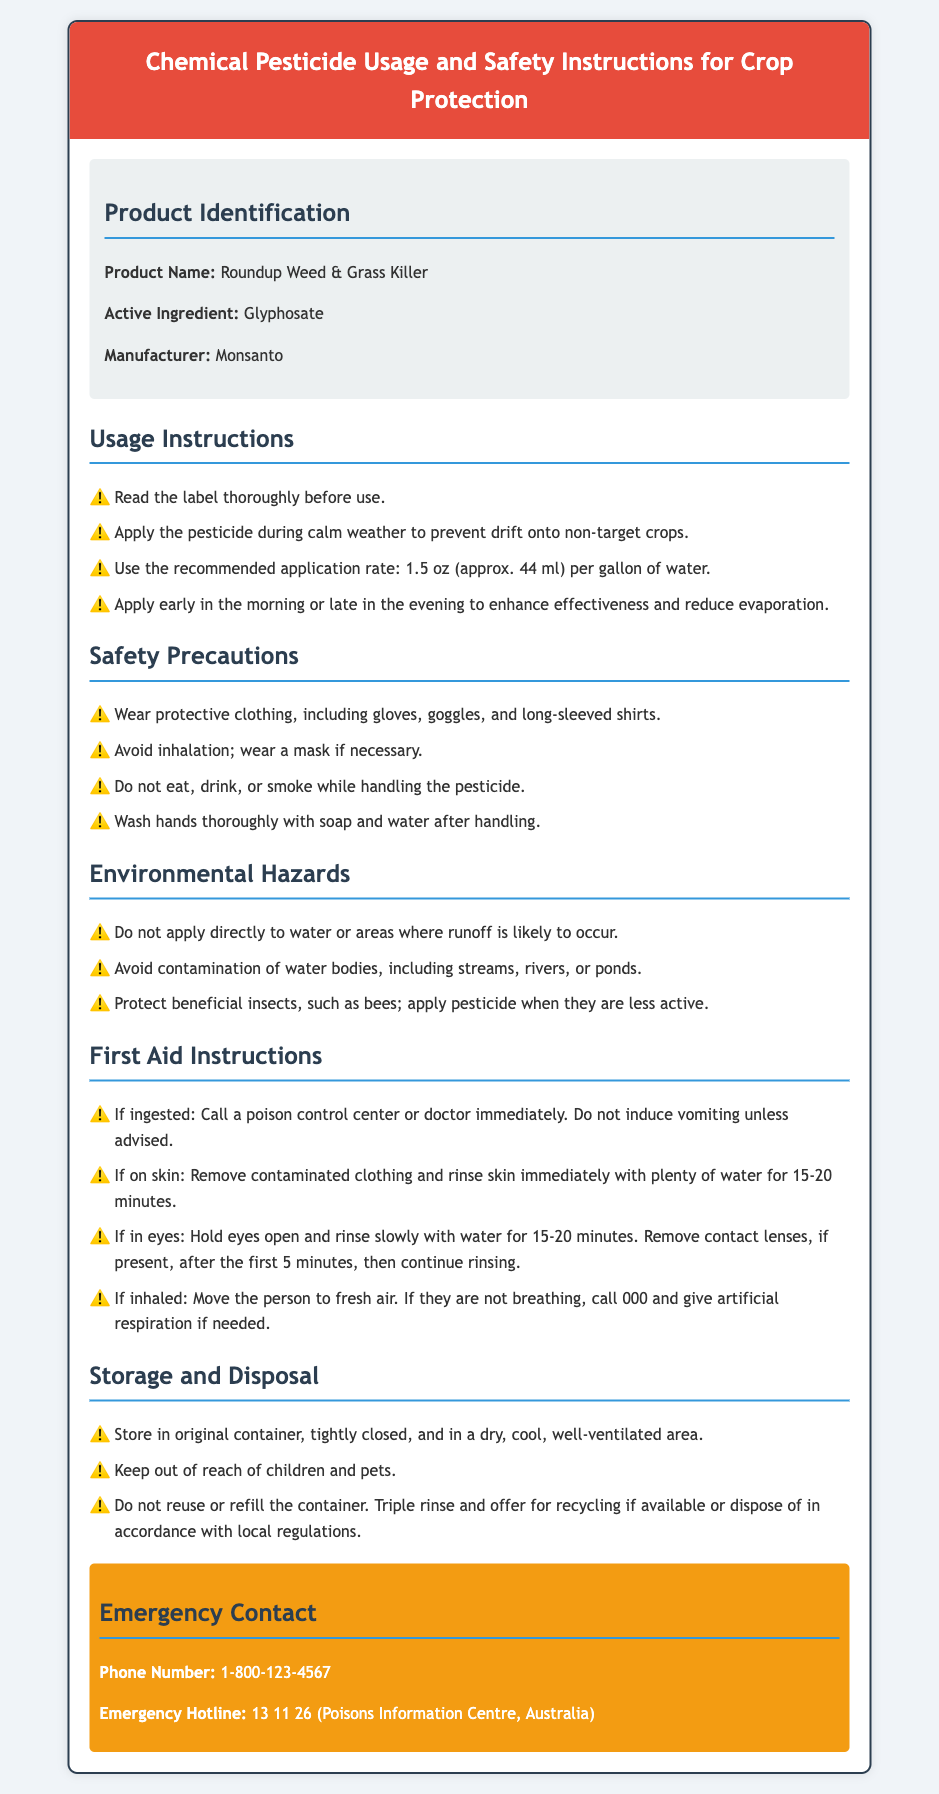What is the product name? The product name is specified in the product identification section of the document.
Answer: Roundup Weed & Grass Killer What is the active ingredient? The active ingredient is listed in the product identification section of the document.
Answer: Glyphosate What protective gear should be worn? The safety precautions section specifies clothing requirements for handling the pesticide.
Answer: Gloves, goggles, long-sleeved shirts What is the recommended application rate? The usage instructions detail the application rate for the pesticide.
Answer: 1.5 oz per gallon of water What should be done if ingestion occurs? The first aid instructions outline actions to take if the pesticide is ingested.
Answer: Call a poison control center or doctor immediately What is the emergency hotline number? The emergency contact section provides a specific hotline number for urgent situations.
Answer: 13 11 26 When should the pesticide be applied? The usage instructions recommend specific times for application to enhance effectiveness.
Answer: Early in the morning or late in the evening What should be avoided to protect beneficial insects? The environmental hazards section advises on actions to protect beneficial insects during pesticide application.
Answer: Applying pesticide when bees are active 